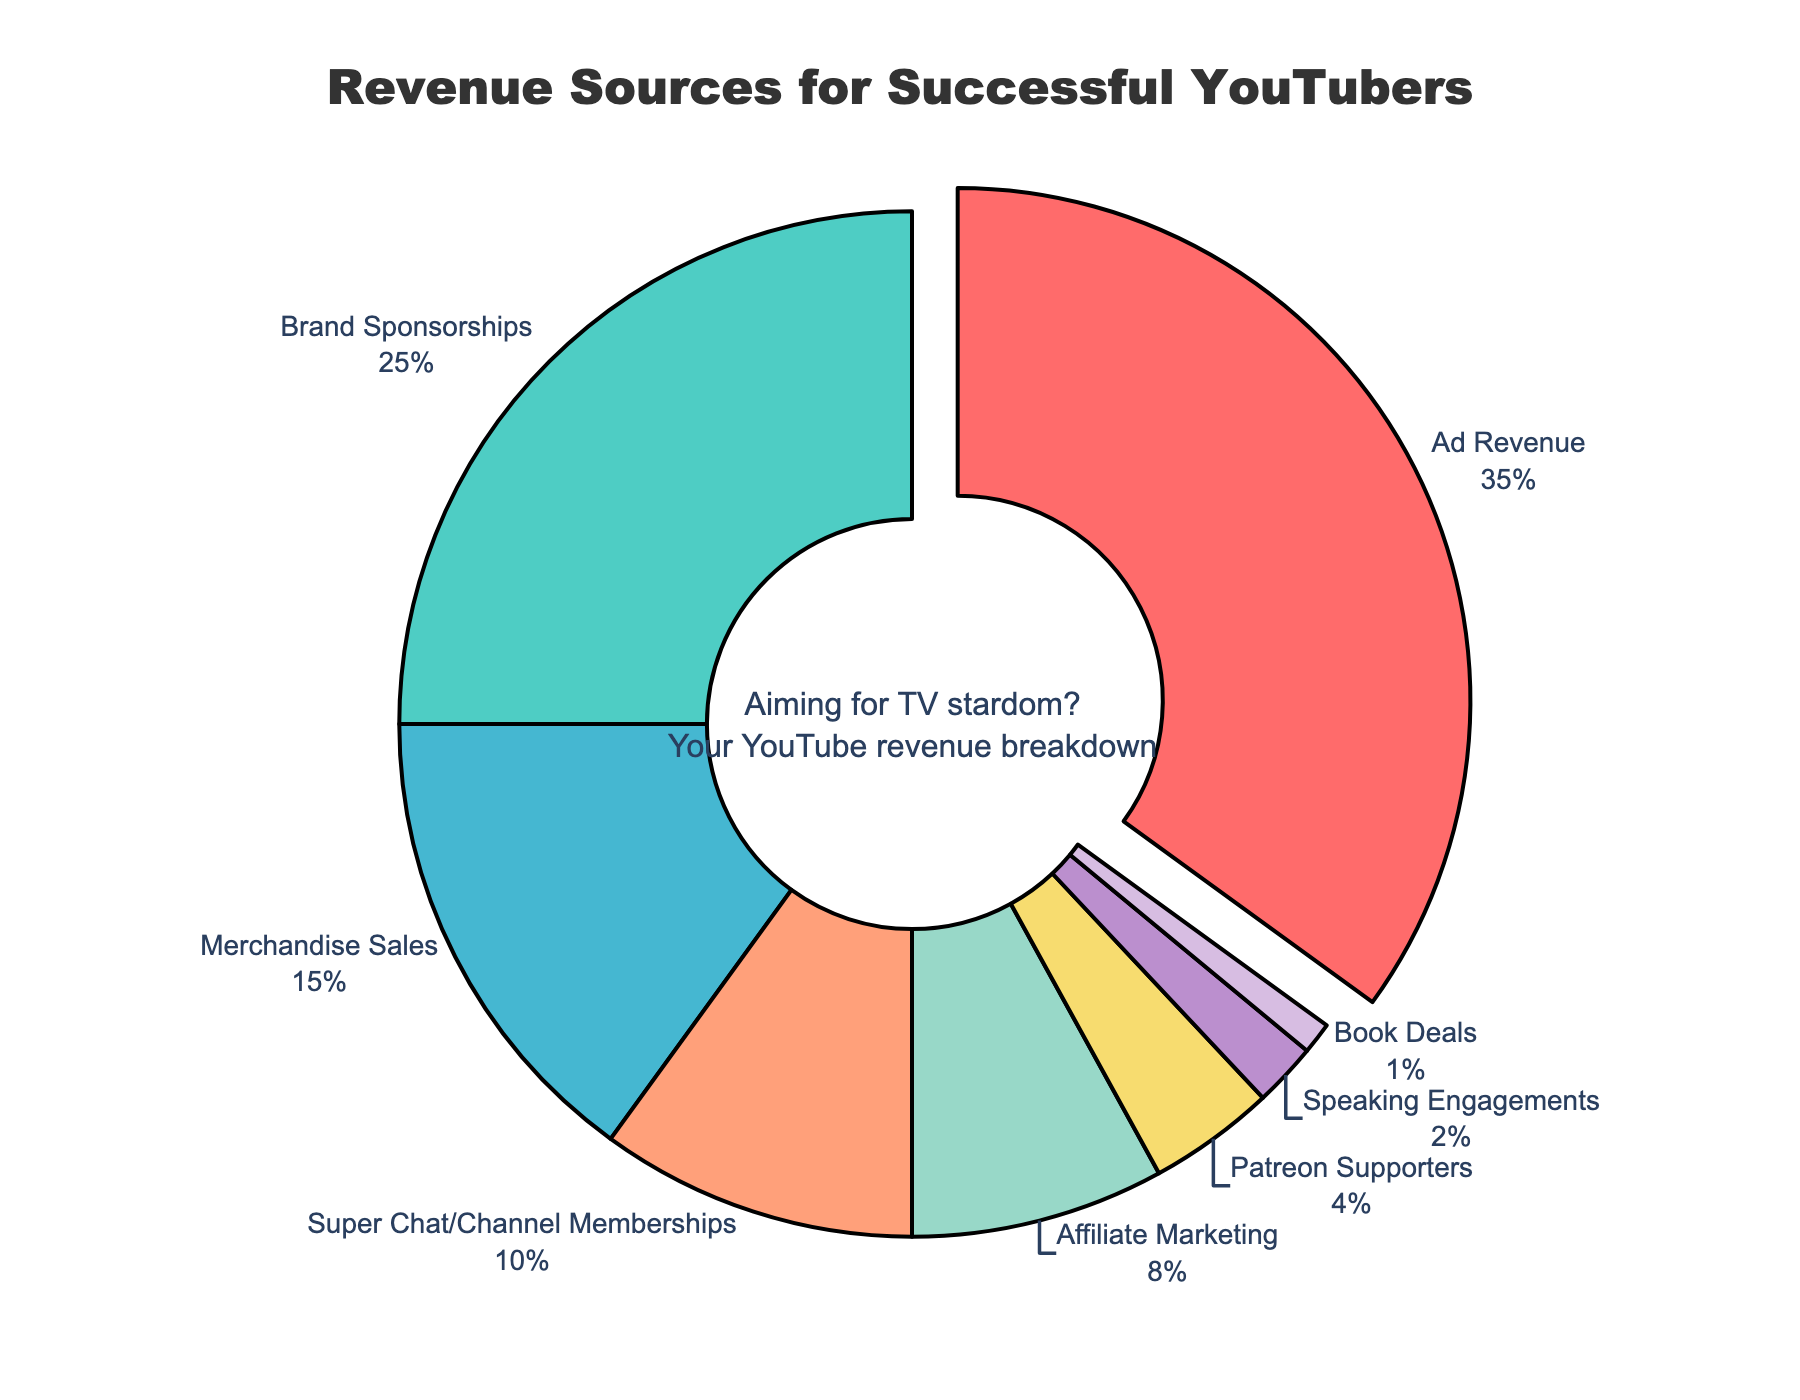what is the largest revenue source for successful YouTubers? The figure's largest segment is labeled "Ad Revenue" and pulled slightly out from the circle, indicating it is the largest revenue source.
Answer: Ad Revenue which revenue source comprises less than 5% of the total? Looking at the figure, "Patreon Supporters", "Speaking Engagements", and "Book Deals" each comprise less than 5% of the total.
Answer: Patreon Supporters, Speaking Engagements, Book Deals how does the percentage of Brand Sponsorships compare to Merchandise Sales? From the figure, Brand Sponsorships are 25% and Merchandise Sales are 15%. Therefore, Brand Sponsorships are 10% higher.
Answer: Brand Sponsorships are 10% higher if you combine the percentages of Super Chat/Channel Memberships and Affiliate Marketing, what is the total percentage? Both Super Chat/Channel Memberships and Affiliate Marketing contribute 10% and 8% respectively. Summing these gives 10% + 8% = 18%.
Answer: 18% which revenue source contributes the least? From the figure, the smallest segment is labeled "Book Deals" at 1%.
Answer: Book Deals what are the second and third largest revenue sources for successful YouTubers? The figure shows Brand Sponsorships at 25% and Merchandise Sales at 15%, making them the second and third largest revenue sources respectively.
Answer: Brand Sponsorships and Merchandise Sales what is the total percentage of income coming from non-advertising sources? Adding percentages of Brand Sponsorships (25%), Merchandise Sales (15%), Super Chat/Channel Memberships (10%), Affiliate Marketing (8%), Patreon Supporters (4%), Speaking Engagements (2%), and Book Deals (1%) gives 25% + 15% + 10% + 8% + 4% + 2% + 1% = 65%.
Answer: 65% how much more revenue percentage does Ad Revenue generate compared to Super Chat/Channel Memberships? Ad Revenue generates 35% while Super Chat/Channel Memberships generate 10%. The difference is 35% - 10% = 25%.
Answer: 25% which segments are colored green and yellow? In the figure, the green segment represents Brand Sponsorships, and the yellow segment represents Affiliate Marketing.
Answer: Brand Sponsorships and Affiliate Marketing 